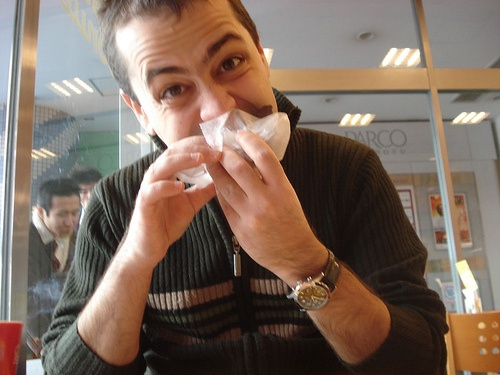Describe the objects in this image and their specific colors. I can see people in darkgray, black, brown, salmon, and maroon tones, chair in darkgray, red, and tan tones, and cup in darkgray, brown, and maroon tones in this image. 